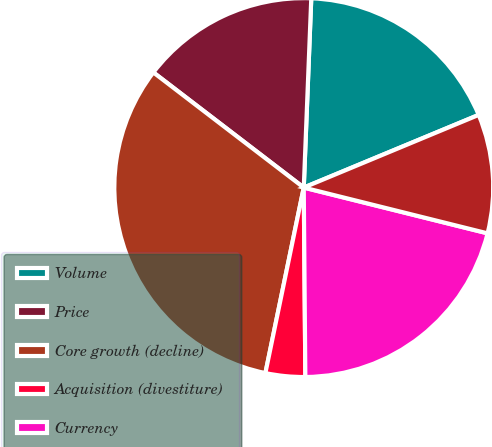Convert chart. <chart><loc_0><loc_0><loc_500><loc_500><pie_chart><fcel>Volume<fcel>Price<fcel>Core growth (decline)<fcel>Acquisition (divestiture)<fcel>Currency<fcel>Total<nl><fcel>18.1%<fcel>15.23%<fcel>32.15%<fcel>3.38%<fcel>20.98%<fcel>10.15%<nl></chart> 